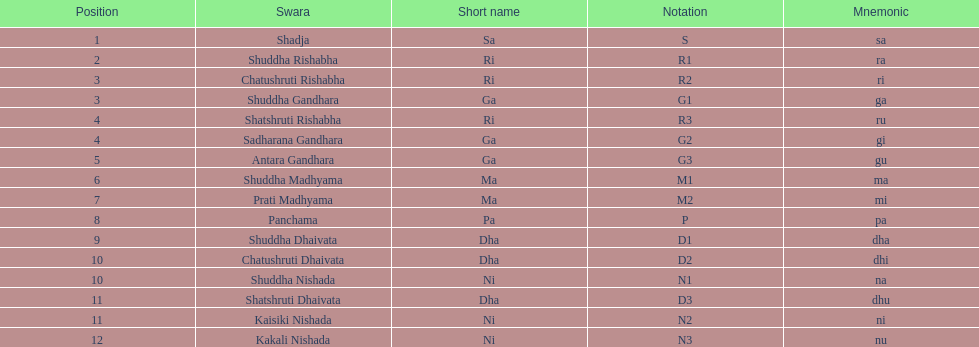After antara gandhara, which swara is next in sequence? Shuddha Madhyama. 